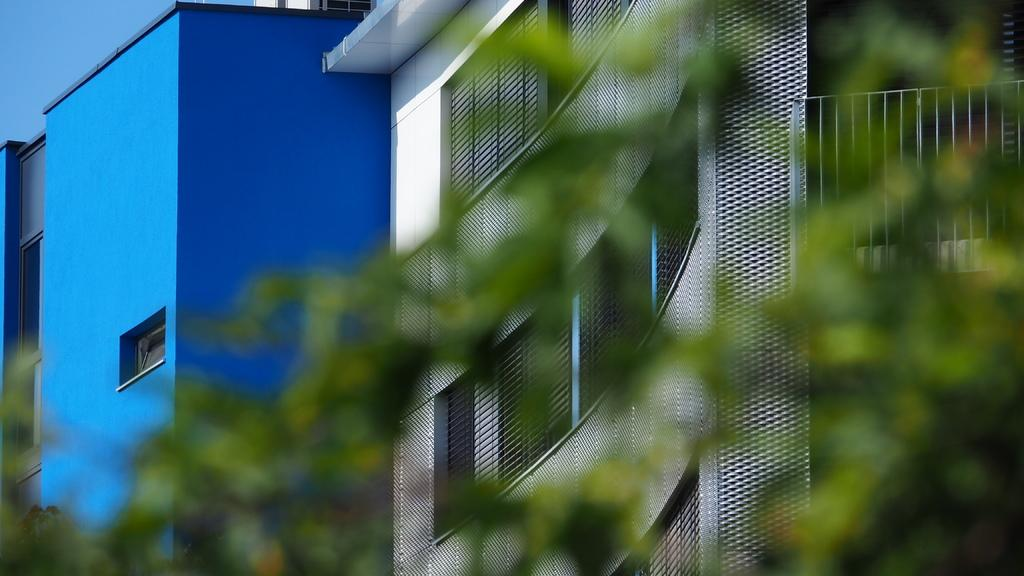What type of vegetation can be seen in the image? There are branches with leaves in the image. What can be seen in the background of the image? There are buildings in the background of the image. What part of the natural environment is visible in the image? The sky is visible in the top left corner of the image. What type of berry is being read by the creature in the image? There is no berry or creature present in the image. 